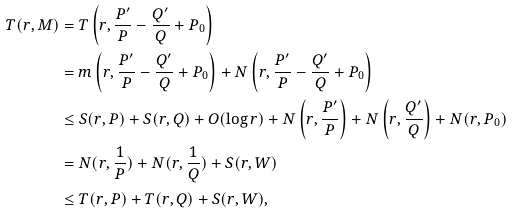<formula> <loc_0><loc_0><loc_500><loc_500>T ( r , M ) & = T \left ( r , \frac { P ^ { \prime } } { P } - \frac { Q ^ { \prime } } { Q } + P _ { 0 } \right ) \\ & = m \left ( r , \frac { P ^ { \prime } } { P } - \frac { Q ^ { \prime } } { Q } + P _ { 0 } \right ) + N \left ( r , \frac { P ^ { \prime } } { P } - \frac { Q ^ { \prime } } { Q } + P _ { 0 } \right ) \\ & \leq S ( r , P ) + S ( r , Q ) + O ( \log r ) + N \left ( r , \frac { P ^ { \prime } } { P } \right ) + N \left ( r , \frac { Q ^ { \prime } } { Q } \right ) + N ( r , P _ { 0 } ) \\ & = N ( r , \frac { 1 } { P } ) + N ( r , \frac { 1 } { Q } ) + S ( r , W ) \\ & \leq T ( r , P ) + T ( r , Q ) + S ( r , W ) ,</formula> 